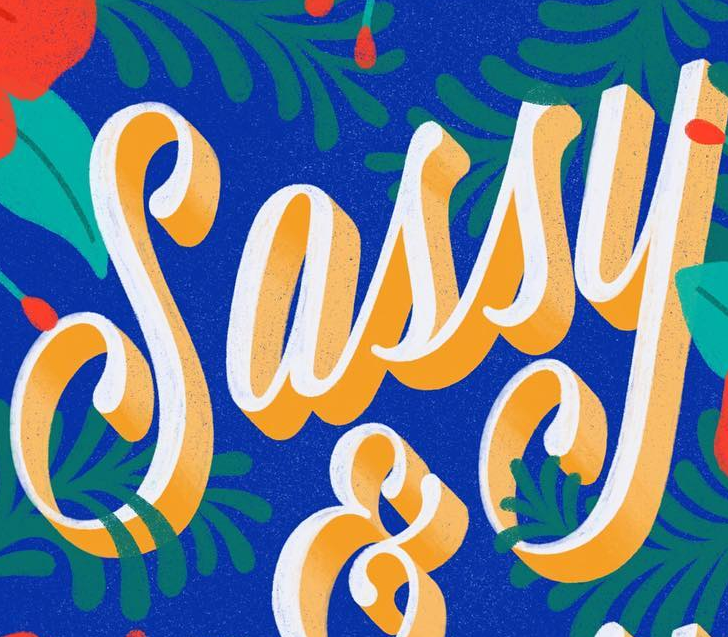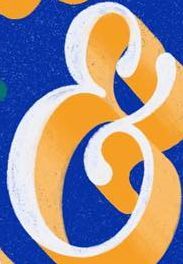What text appears in these images from left to right, separated by a semicolon? Sassy; & 